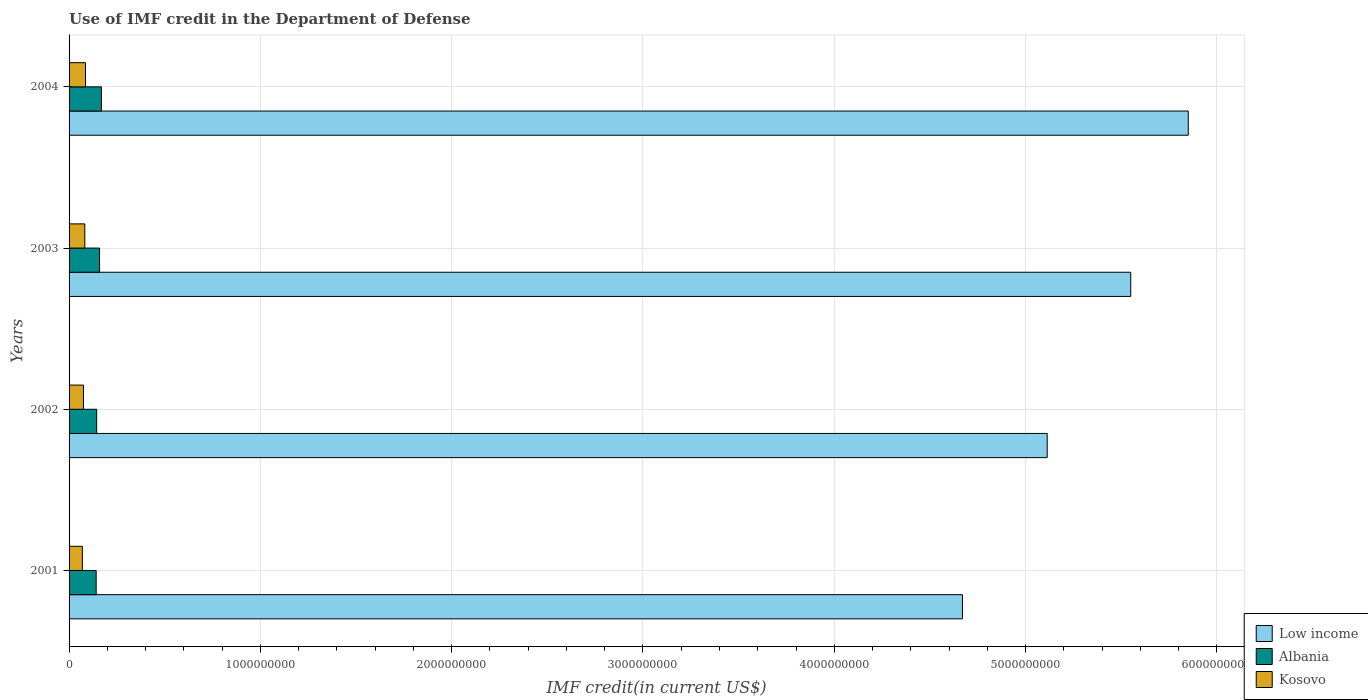How many different coloured bars are there?
Offer a very short reply. 3. How many groups of bars are there?
Your answer should be very brief. 4. Are the number of bars on each tick of the Y-axis equal?
Provide a short and direct response. Yes. How many bars are there on the 3rd tick from the bottom?
Your response must be concise. 3. What is the label of the 4th group of bars from the top?
Provide a succinct answer. 2001. What is the IMF credit in the Department of Defense in Kosovo in 2002?
Offer a terse response. 7.53e+07. Across all years, what is the maximum IMF credit in the Department of Defense in Albania?
Give a very brief answer. 1.69e+08. Across all years, what is the minimum IMF credit in the Department of Defense in Low income?
Your answer should be very brief. 4.67e+09. In which year was the IMF credit in the Department of Defense in Low income maximum?
Your answer should be compact. 2004. What is the total IMF credit in the Department of Defense in Albania in the graph?
Give a very brief answer. 6.14e+08. What is the difference between the IMF credit in the Department of Defense in Albania in 2001 and that in 2003?
Keep it short and to the point. -1.78e+07. What is the difference between the IMF credit in the Department of Defense in Albania in 2003 and the IMF credit in the Department of Defense in Kosovo in 2002?
Give a very brief answer. 8.41e+07. What is the average IMF credit in the Department of Defense in Kosovo per year?
Keep it short and to the point. 7.83e+07. In the year 2001, what is the difference between the IMF credit in the Department of Defense in Albania and IMF credit in the Department of Defense in Kosovo?
Your response must be concise. 7.21e+07. What is the ratio of the IMF credit in the Department of Defense in Low income in 2001 to that in 2002?
Your response must be concise. 0.91. Is the IMF credit in the Department of Defense in Low income in 2002 less than that in 2003?
Provide a short and direct response. Yes. Is the difference between the IMF credit in the Department of Defense in Albania in 2003 and 2004 greater than the difference between the IMF credit in the Department of Defense in Kosovo in 2003 and 2004?
Provide a succinct answer. No. What is the difference between the highest and the second highest IMF credit in the Department of Defense in Low income?
Make the answer very short. 3.01e+08. What is the difference between the highest and the lowest IMF credit in the Department of Defense in Albania?
Keep it short and to the point. 2.75e+07. What does the 1st bar from the top in 2004 represents?
Offer a very short reply. Kosovo. What does the 3rd bar from the bottom in 2002 represents?
Ensure brevity in your answer.  Kosovo. Is it the case that in every year, the sum of the IMF credit in the Department of Defense in Low income and IMF credit in the Department of Defense in Kosovo is greater than the IMF credit in the Department of Defense in Albania?
Make the answer very short. Yes. How many years are there in the graph?
Keep it short and to the point. 4. Does the graph contain grids?
Provide a succinct answer. Yes. Where does the legend appear in the graph?
Keep it short and to the point. Bottom right. How are the legend labels stacked?
Give a very brief answer. Vertical. What is the title of the graph?
Provide a succinct answer. Use of IMF credit in the Department of Defense. What is the label or title of the X-axis?
Offer a very short reply. IMF credit(in current US$). What is the IMF credit(in current US$) in Low income in 2001?
Your answer should be compact. 4.67e+09. What is the IMF credit(in current US$) of Albania in 2001?
Offer a very short reply. 1.42e+08. What is the IMF credit(in current US$) in Kosovo in 2001?
Your answer should be compact. 6.96e+07. What is the IMF credit(in current US$) in Low income in 2002?
Provide a short and direct response. 5.11e+09. What is the IMF credit(in current US$) in Albania in 2002?
Offer a very short reply. 1.44e+08. What is the IMF credit(in current US$) in Kosovo in 2002?
Make the answer very short. 7.53e+07. What is the IMF credit(in current US$) in Low income in 2003?
Provide a succinct answer. 5.55e+09. What is the IMF credit(in current US$) in Albania in 2003?
Your answer should be very brief. 1.59e+08. What is the IMF credit(in current US$) of Kosovo in 2003?
Offer a very short reply. 8.23e+07. What is the IMF credit(in current US$) of Low income in 2004?
Provide a short and direct response. 5.85e+09. What is the IMF credit(in current US$) in Albania in 2004?
Give a very brief answer. 1.69e+08. What is the IMF credit(in current US$) of Kosovo in 2004?
Your answer should be very brief. 8.60e+07. Across all years, what is the maximum IMF credit(in current US$) of Low income?
Your answer should be very brief. 5.85e+09. Across all years, what is the maximum IMF credit(in current US$) in Albania?
Ensure brevity in your answer.  1.69e+08. Across all years, what is the maximum IMF credit(in current US$) in Kosovo?
Provide a short and direct response. 8.60e+07. Across all years, what is the minimum IMF credit(in current US$) in Low income?
Your answer should be compact. 4.67e+09. Across all years, what is the minimum IMF credit(in current US$) of Albania?
Ensure brevity in your answer.  1.42e+08. Across all years, what is the minimum IMF credit(in current US$) of Kosovo?
Provide a succinct answer. 6.96e+07. What is the total IMF credit(in current US$) of Low income in the graph?
Keep it short and to the point. 2.12e+1. What is the total IMF credit(in current US$) in Albania in the graph?
Keep it short and to the point. 6.14e+08. What is the total IMF credit(in current US$) in Kosovo in the graph?
Ensure brevity in your answer.  3.13e+08. What is the difference between the IMF credit(in current US$) of Low income in 2001 and that in 2002?
Make the answer very short. -4.43e+08. What is the difference between the IMF credit(in current US$) in Albania in 2001 and that in 2002?
Ensure brevity in your answer.  -2.58e+06. What is the difference between the IMF credit(in current US$) in Kosovo in 2001 and that in 2002?
Provide a short and direct response. -5.69e+06. What is the difference between the IMF credit(in current US$) of Low income in 2001 and that in 2003?
Ensure brevity in your answer.  -8.80e+08. What is the difference between the IMF credit(in current US$) of Albania in 2001 and that in 2003?
Offer a very short reply. -1.78e+07. What is the difference between the IMF credit(in current US$) of Kosovo in 2001 and that in 2003?
Your answer should be compact. -1.27e+07. What is the difference between the IMF credit(in current US$) in Low income in 2001 and that in 2004?
Offer a terse response. -1.18e+09. What is the difference between the IMF credit(in current US$) in Albania in 2001 and that in 2004?
Keep it short and to the point. -2.75e+07. What is the difference between the IMF credit(in current US$) in Kosovo in 2001 and that in 2004?
Provide a short and direct response. -1.64e+07. What is the difference between the IMF credit(in current US$) in Low income in 2002 and that in 2003?
Your answer should be very brief. -4.37e+08. What is the difference between the IMF credit(in current US$) in Albania in 2002 and that in 2003?
Offer a very short reply. -1.52e+07. What is the difference between the IMF credit(in current US$) of Kosovo in 2002 and that in 2003?
Your answer should be very brief. -7.00e+06. What is the difference between the IMF credit(in current US$) of Low income in 2002 and that in 2004?
Make the answer very short. -7.37e+08. What is the difference between the IMF credit(in current US$) of Albania in 2002 and that in 2004?
Your answer should be compact. -2.49e+07. What is the difference between the IMF credit(in current US$) of Kosovo in 2002 and that in 2004?
Provide a short and direct response. -1.07e+07. What is the difference between the IMF credit(in current US$) of Low income in 2003 and that in 2004?
Make the answer very short. -3.01e+08. What is the difference between the IMF credit(in current US$) of Albania in 2003 and that in 2004?
Give a very brief answer. -9.69e+06. What is the difference between the IMF credit(in current US$) in Kosovo in 2003 and that in 2004?
Your response must be concise. -3.71e+06. What is the difference between the IMF credit(in current US$) of Low income in 2001 and the IMF credit(in current US$) of Albania in 2002?
Offer a very short reply. 4.53e+09. What is the difference between the IMF credit(in current US$) of Low income in 2001 and the IMF credit(in current US$) of Kosovo in 2002?
Ensure brevity in your answer.  4.59e+09. What is the difference between the IMF credit(in current US$) of Albania in 2001 and the IMF credit(in current US$) of Kosovo in 2002?
Offer a terse response. 6.64e+07. What is the difference between the IMF credit(in current US$) of Low income in 2001 and the IMF credit(in current US$) of Albania in 2003?
Provide a succinct answer. 4.51e+09. What is the difference between the IMF credit(in current US$) of Low income in 2001 and the IMF credit(in current US$) of Kosovo in 2003?
Your answer should be compact. 4.59e+09. What is the difference between the IMF credit(in current US$) of Albania in 2001 and the IMF credit(in current US$) of Kosovo in 2003?
Keep it short and to the point. 5.94e+07. What is the difference between the IMF credit(in current US$) in Low income in 2001 and the IMF credit(in current US$) in Albania in 2004?
Offer a very short reply. 4.50e+09. What is the difference between the IMF credit(in current US$) in Low income in 2001 and the IMF credit(in current US$) in Kosovo in 2004?
Offer a terse response. 4.58e+09. What is the difference between the IMF credit(in current US$) of Albania in 2001 and the IMF credit(in current US$) of Kosovo in 2004?
Your answer should be compact. 5.56e+07. What is the difference between the IMF credit(in current US$) in Low income in 2002 and the IMF credit(in current US$) in Albania in 2003?
Provide a succinct answer. 4.95e+09. What is the difference between the IMF credit(in current US$) in Low income in 2002 and the IMF credit(in current US$) in Kosovo in 2003?
Provide a succinct answer. 5.03e+09. What is the difference between the IMF credit(in current US$) of Albania in 2002 and the IMF credit(in current US$) of Kosovo in 2003?
Provide a succinct answer. 6.19e+07. What is the difference between the IMF credit(in current US$) in Low income in 2002 and the IMF credit(in current US$) in Albania in 2004?
Provide a short and direct response. 4.94e+09. What is the difference between the IMF credit(in current US$) in Low income in 2002 and the IMF credit(in current US$) in Kosovo in 2004?
Make the answer very short. 5.03e+09. What is the difference between the IMF credit(in current US$) in Albania in 2002 and the IMF credit(in current US$) in Kosovo in 2004?
Provide a short and direct response. 5.82e+07. What is the difference between the IMF credit(in current US$) of Low income in 2003 and the IMF credit(in current US$) of Albania in 2004?
Ensure brevity in your answer.  5.38e+09. What is the difference between the IMF credit(in current US$) in Low income in 2003 and the IMF credit(in current US$) in Kosovo in 2004?
Keep it short and to the point. 5.46e+09. What is the difference between the IMF credit(in current US$) in Albania in 2003 and the IMF credit(in current US$) in Kosovo in 2004?
Offer a terse response. 7.34e+07. What is the average IMF credit(in current US$) of Low income per year?
Give a very brief answer. 5.30e+09. What is the average IMF credit(in current US$) in Albania per year?
Make the answer very short. 1.54e+08. What is the average IMF credit(in current US$) in Kosovo per year?
Your answer should be compact. 7.83e+07. In the year 2001, what is the difference between the IMF credit(in current US$) of Low income and IMF credit(in current US$) of Albania?
Provide a short and direct response. 4.53e+09. In the year 2001, what is the difference between the IMF credit(in current US$) of Low income and IMF credit(in current US$) of Kosovo?
Give a very brief answer. 4.60e+09. In the year 2001, what is the difference between the IMF credit(in current US$) of Albania and IMF credit(in current US$) of Kosovo?
Make the answer very short. 7.21e+07. In the year 2002, what is the difference between the IMF credit(in current US$) of Low income and IMF credit(in current US$) of Albania?
Offer a very short reply. 4.97e+09. In the year 2002, what is the difference between the IMF credit(in current US$) in Low income and IMF credit(in current US$) in Kosovo?
Your answer should be compact. 5.04e+09. In the year 2002, what is the difference between the IMF credit(in current US$) of Albania and IMF credit(in current US$) of Kosovo?
Ensure brevity in your answer.  6.89e+07. In the year 2003, what is the difference between the IMF credit(in current US$) of Low income and IMF credit(in current US$) of Albania?
Provide a short and direct response. 5.39e+09. In the year 2003, what is the difference between the IMF credit(in current US$) in Low income and IMF credit(in current US$) in Kosovo?
Provide a short and direct response. 5.47e+09. In the year 2003, what is the difference between the IMF credit(in current US$) in Albania and IMF credit(in current US$) in Kosovo?
Keep it short and to the point. 7.71e+07. In the year 2004, what is the difference between the IMF credit(in current US$) of Low income and IMF credit(in current US$) of Albania?
Your answer should be compact. 5.68e+09. In the year 2004, what is the difference between the IMF credit(in current US$) in Low income and IMF credit(in current US$) in Kosovo?
Your answer should be very brief. 5.76e+09. In the year 2004, what is the difference between the IMF credit(in current US$) of Albania and IMF credit(in current US$) of Kosovo?
Your response must be concise. 8.31e+07. What is the ratio of the IMF credit(in current US$) of Low income in 2001 to that in 2002?
Your response must be concise. 0.91. What is the ratio of the IMF credit(in current US$) in Albania in 2001 to that in 2002?
Ensure brevity in your answer.  0.98. What is the ratio of the IMF credit(in current US$) in Kosovo in 2001 to that in 2002?
Make the answer very short. 0.92. What is the ratio of the IMF credit(in current US$) of Low income in 2001 to that in 2003?
Offer a terse response. 0.84. What is the ratio of the IMF credit(in current US$) of Albania in 2001 to that in 2003?
Your answer should be very brief. 0.89. What is the ratio of the IMF credit(in current US$) in Kosovo in 2001 to that in 2003?
Make the answer very short. 0.85. What is the ratio of the IMF credit(in current US$) in Low income in 2001 to that in 2004?
Offer a terse response. 0.8. What is the ratio of the IMF credit(in current US$) in Albania in 2001 to that in 2004?
Your answer should be very brief. 0.84. What is the ratio of the IMF credit(in current US$) in Kosovo in 2001 to that in 2004?
Your response must be concise. 0.81. What is the ratio of the IMF credit(in current US$) of Low income in 2002 to that in 2003?
Provide a succinct answer. 0.92. What is the ratio of the IMF credit(in current US$) in Albania in 2002 to that in 2003?
Your answer should be very brief. 0.9. What is the ratio of the IMF credit(in current US$) in Kosovo in 2002 to that in 2003?
Offer a very short reply. 0.91. What is the ratio of the IMF credit(in current US$) of Low income in 2002 to that in 2004?
Make the answer very short. 0.87. What is the ratio of the IMF credit(in current US$) in Albania in 2002 to that in 2004?
Your response must be concise. 0.85. What is the ratio of the IMF credit(in current US$) in Kosovo in 2002 to that in 2004?
Provide a short and direct response. 0.88. What is the ratio of the IMF credit(in current US$) in Low income in 2003 to that in 2004?
Offer a very short reply. 0.95. What is the ratio of the IMF credit(in current US$) in Albania in 2003 to that in 2004?
Provide a succinct answer. 0.94. What is the ratio of the IMF credit(in current US$) in Kosovo in 2003 to that in 2004?
Offer a terse response. 0.96. What is the difference between the highest and the second highest IMF credit(in current US$) of Low income?
Ensure brevity in your answer.  3.01e+08. What is the difference between the highest and the second highest IMF credit(in current US$) of Albania?
Keep it short and to the point. 9.69e+06. What is the difference between the highest and the second highest IMF credit(in current US$) of Kosovo?
Keep it short and to the point. 3.71e+06. What is the difference between the highest and the lowest IMF credit(in current US$) in Low income?
Your response must be concise. 1.18e+09. What is the difference between the highest and the lowest IMF credit(in current US$) of Albania?
Provide a succinct answer. 2.75e+07. What is the difference between the highest and the lowest IMF credit(in current US$) of Kosovo?
Your answer should be very brief. 1.64e+07. 